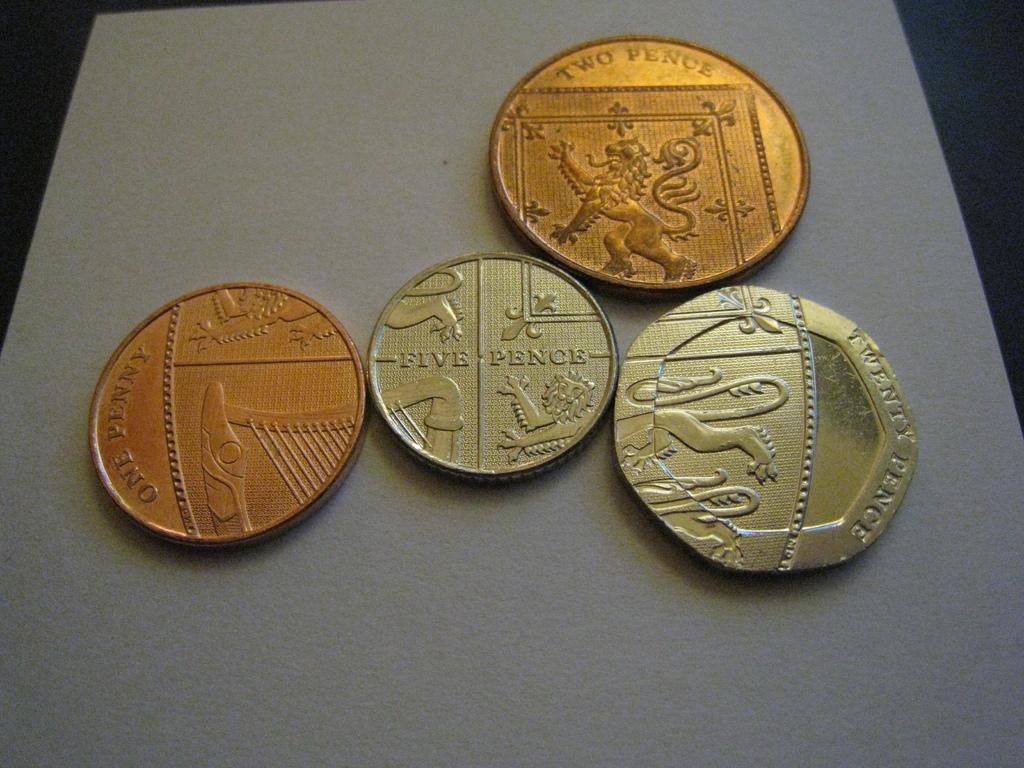How many currency coins are visible in the image? There are four currency coins in the image. What is the color of the table on which the coins are placed? The coins are placed on a white table. What can be said about the color of two of the coins? Two of the coins have a dark gold color. What type of lead can be seen on the side of the coins in the image? There is no lead visible on the coins in the image, and the coins do not have a side that can be observed in the image. 